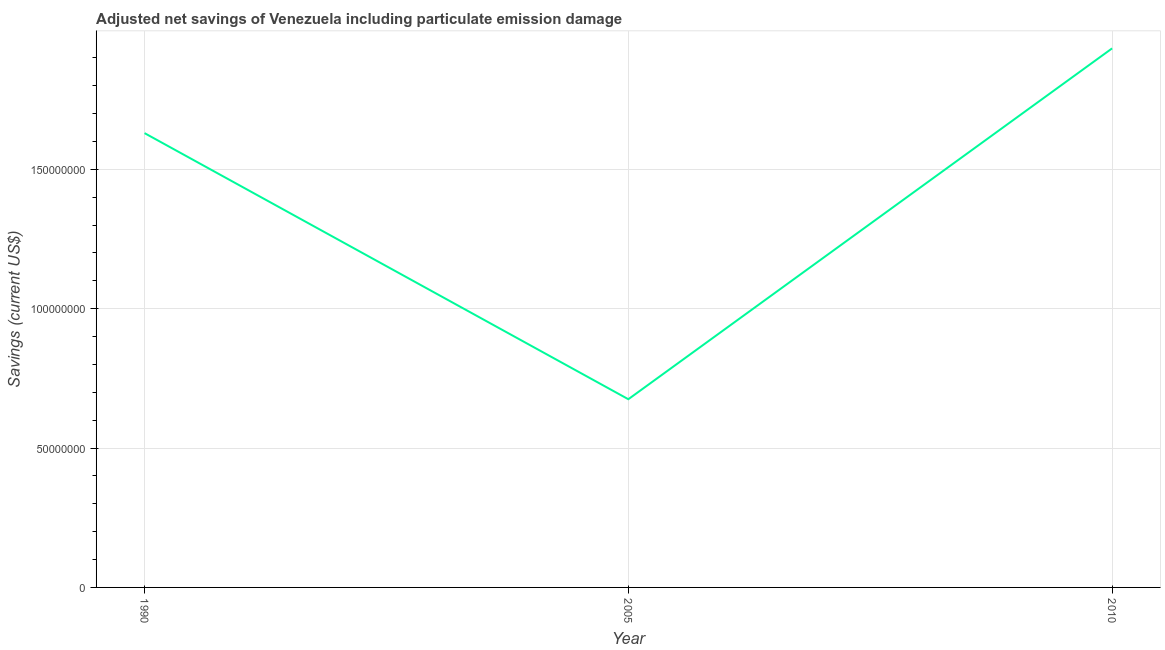What is the adjusted net savings in 2010?
Your response must be concise. 1.93e+08. Across all years, what is the maximum adjusted net savings?
Your answer should be very brief. 1.93e+08. Across all years, what is the minimum adjusted net savings?
Keep it short and to the point. 6.75e+07. In which year was the adjusted net savings minimum?
Ensure brevity in your answer.  2005. What is the sum of the adjusted net savings?
Your response must be concise. 4.24e+08. What is the difference between the adjusted net savings in 1990 and 2010?
Offer a terse response. -3.04e+07. What is the average adjusted net savings per year?
Keep it short and to the point. 1.41e+08. What is the median adjusted net savings?
Provide a short and direct response. 1.63e+08. In how many years, is the adjusted net savings greater than 110000000 US$?
Your answer should be compact. 2. Do a majority of the years between 1990 and 2010 (inclusive) have adjusted net savings greater than 90000000 US$?
Your answer should be compact. Yes. What is the ratio of the adjusted net savings in 1990 to that in 2010?
Offer a terse response. 0.84. Is the difference between the adjusted net savings in 1990 and 2005 greater than the difference between any two years?
Offer a terse response. No. What is the difference between the highest and the second highest adjusted net savings?
Offer a very short reply. 3.04e+07. Is the sum of the adjusted net savings in 1990 and 2010 greater than the maximum adjusted net savings across all years?
Ensure brevity in your answer.  Yes. What is the difference between the highest and the lowest adjusted net savings?
Keep it short and to the point. 1.26e+08. In how many years, is the adjusted net savings greater than the average adjusted net savings taken over all years?
Provide a succinct answer. 2. How many years are there in the graph?
Make the answer very short. 3. Are the values on the major ticks of Y-axis written in scientific E-notation?
Keep it short and to the point. No. Does the graph contain grids?
Give a very brief answer. Yes. What is the title of the graph?
Keep it short and to the point. Adjusted net savings of Venezuela including particulate emission damage. What is the label or title of the X-axis?
Offer a very short reply. Year. What is the label or title of the Y-axis?
Your response must be concise. Savings (current US$). What is the Savings (current US$) of 1990?
Your answer should be very brief. 1.63e+08. What is the Savings (current US$) in 2005?
Offer a very short reply. 6.75e+07. What is the Savings (current US$) in 2010?
Provide a short and direct response. 1.93e+08. What is the difference between the Savings (current US$) in 1990 and 2005?
Make the answer very short. 9.54e+07. What is the difference between the Savings (current US$) in 1990 and 2010?
Your response must be concise. -3.04e+07. What is the difference between the Savings (current US$) in 2005 and 2010?
Provide a succinct answer. -1.26e+08. What is the ratio of the Savings (current US$) in 1990 to that in 2005?
Your response must be concise. 2.41. What is the ratio of the Savings (current US$) in 1990 to that in 2010?
Ensure brevity in your answer.  0.84. What is the ratio of the Savings (current US$) in 2005 to that in 2010?
Provide a succinct answer. 0.35. 